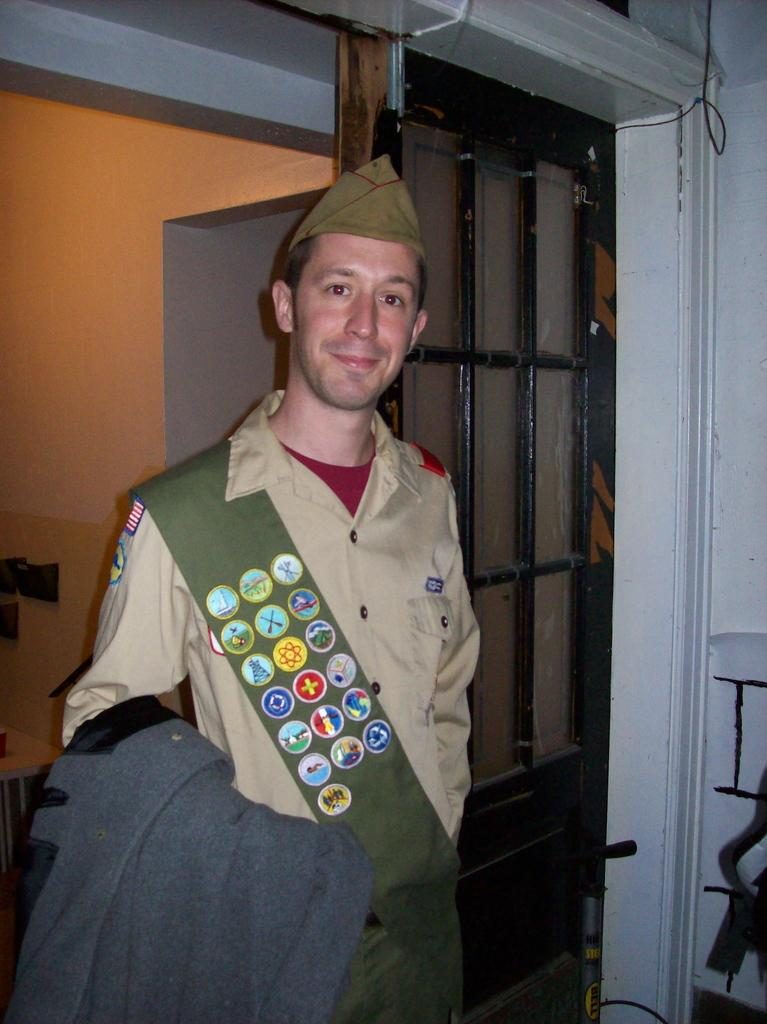Who is present in the image? There is a man in the image. What is the man doing in the image? The man is smiling in the image. What is the man holding in the image? The man is holding a cloth with his hand in the image. What can be seen in the background of the image? There is a wall in the background of the image. Can you see the man giving a sign to someone in the image? There is no indication in the image that the man is giving a sign to someone. 